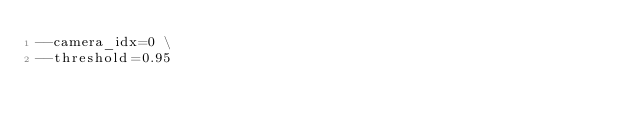Convert code to text. <code><loc_0><loc_0><loc_500><loc_500><_Bash_>--camera_idx=0 \
--threshold=0.95
</code> 